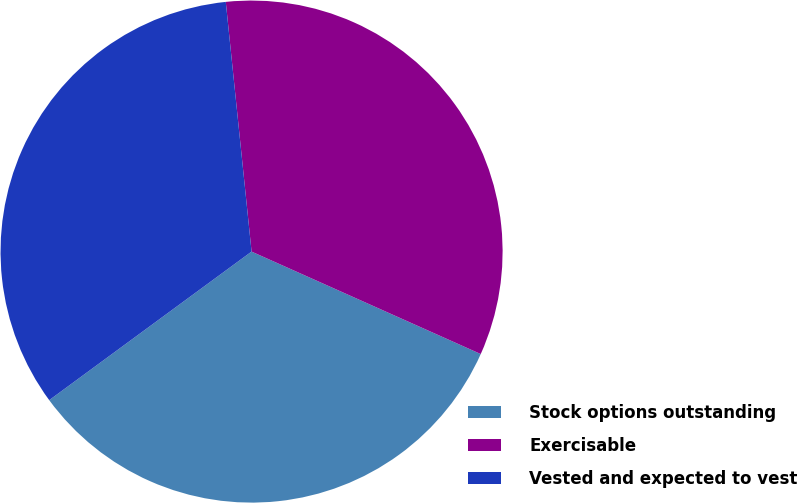Convert chart. <chart><loc_0><loc_0><loc_500><loc_500><pie_chart><fcel>Stock options outstanding<fcel>Exercisable<fcel>Vested and expected to vest<nl><fcel>33.23%<fcel>33.33%<fcel>33.44%<nl></chart> 